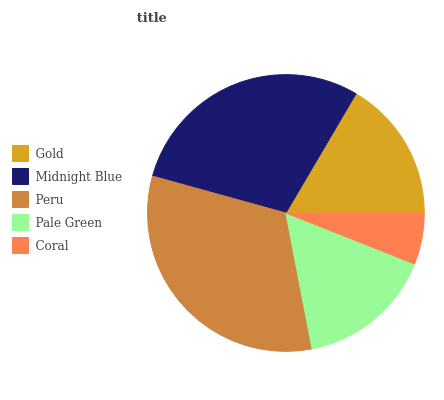Is Coral the minimum?
Answer yes or no. Yes. Is Peru the maximum?
Answer yes or no. Yes. Is Midnight Blue the minimum?
Answer yes or no. No. Is Midnight Blue the maximum?
Answer yes or no. No. Is Midnight Blue greater than Gold?
Answer yes or no. Yes. Is Gold less than Midnight Blue?
Answer yes or no. Yes. Is Gold greater than Midnight Blue?
Answer yes or no. No. Is Midnight Blue less than Gold?
Answer yes or no. No. Is Gold the high median?
Answer yes or no. Yes. Is Gold the low median?
Answer yes or no. Yes. Is Pale Green the high median?
Answer yes or no. No. Is Midnight Blue the low median?
Answer yes or no. No. 